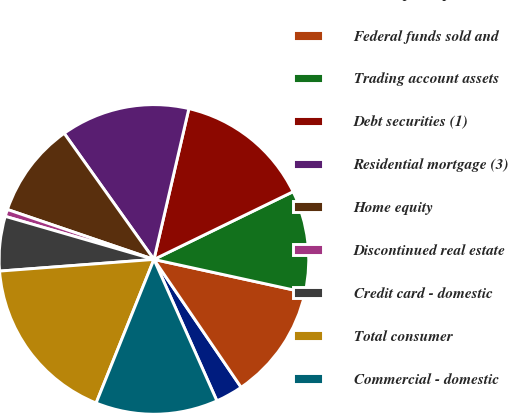<chart> <loc_0><loc_0><loc_500><loc_500><pie_chart><fcel>Time deposits placed and other<fcel>Federal funds sold and<fcel>Trading account assets<fcel>Debt securities (1)<fcel>Residential mortgage (3)<fcel>Home equity<fcel>Discontinued real estate<fcel>Credit card - domestic<fcel>Total consumer<fcel>Commercial - domestic<nl><fcel>2.86%<fcel>12.05%<fcel>10.64%<fcel>14.17%<fcel>13.47%<fcel>9.93%<fcel>0.74%<fcel>5.69%<fcel>17.71%<fcel>12.76%<nl></chart> 